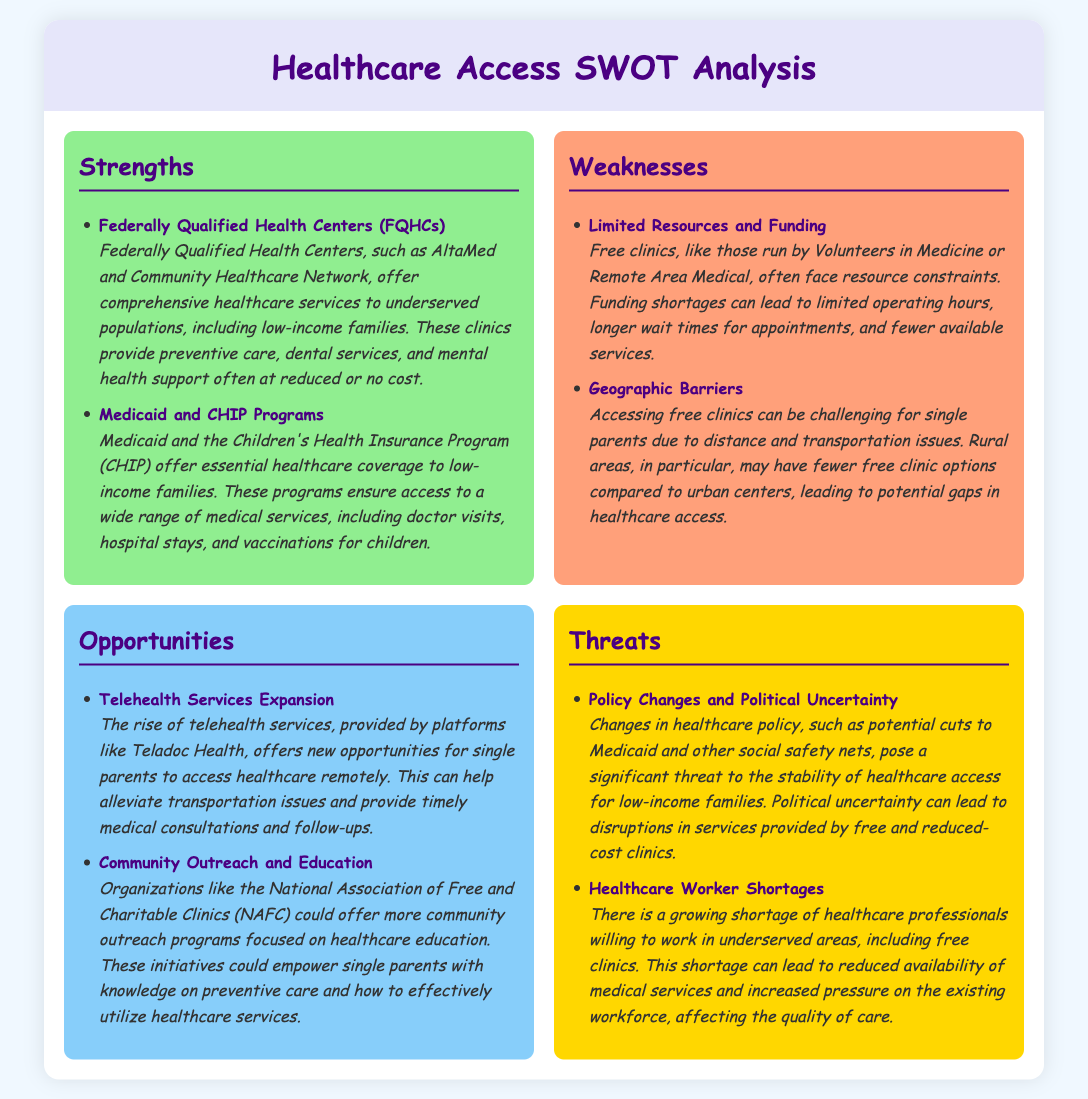What are FQHCs? FQHCs are Federally Qualified Health Centers that provide comprehensive healthcare services to underserved populations.
Answer: Federally Qualified Health Centers What programs offer healthcare coverage to low-income families? The document mentions Medicaid and the Children's Health Insurance Program (CHIP) as essential healthcare coverage programs.
Answer: Medicaid and CHIP What is a major weakness faced by free clinics? One significant weakness is limited resources and funding, leading to reduced operational capabilities.
Answer: Limited Resources and Funding Which opportunity for single parents is highlighted in the analysis? The rise of telehealth services provides new opportunities for remote healthcare access for single parents.
Answer: Telehealth Services Expansion What is a threat related to healthcare workers? The analysis mentions a growing shortage of healthcare professionals willing to work in underserved areas as a threat.
Answer: Healthcare Worker Shortages What type of clinics may face geographic barriers? Free clinics may face geographic barriers, particularly affecting single parents' ability to access them.
Answer: Free clinics Which organization could enhance community outreach? The National Association of Free and Charitable Clinics (NAFC) could offer more community outreach programs.
Answer: National Association of Free and Charitable Clinics How might policy changes impact healthcare access? Changes in healthcare policy may threaten the stability of healthcare access for low-income families.
Answer: Policy Changes What do telehealth services help alleviate? Telehealth services help alleviate transportation issues associated with healthcare access.
Answer: Transportation issues 